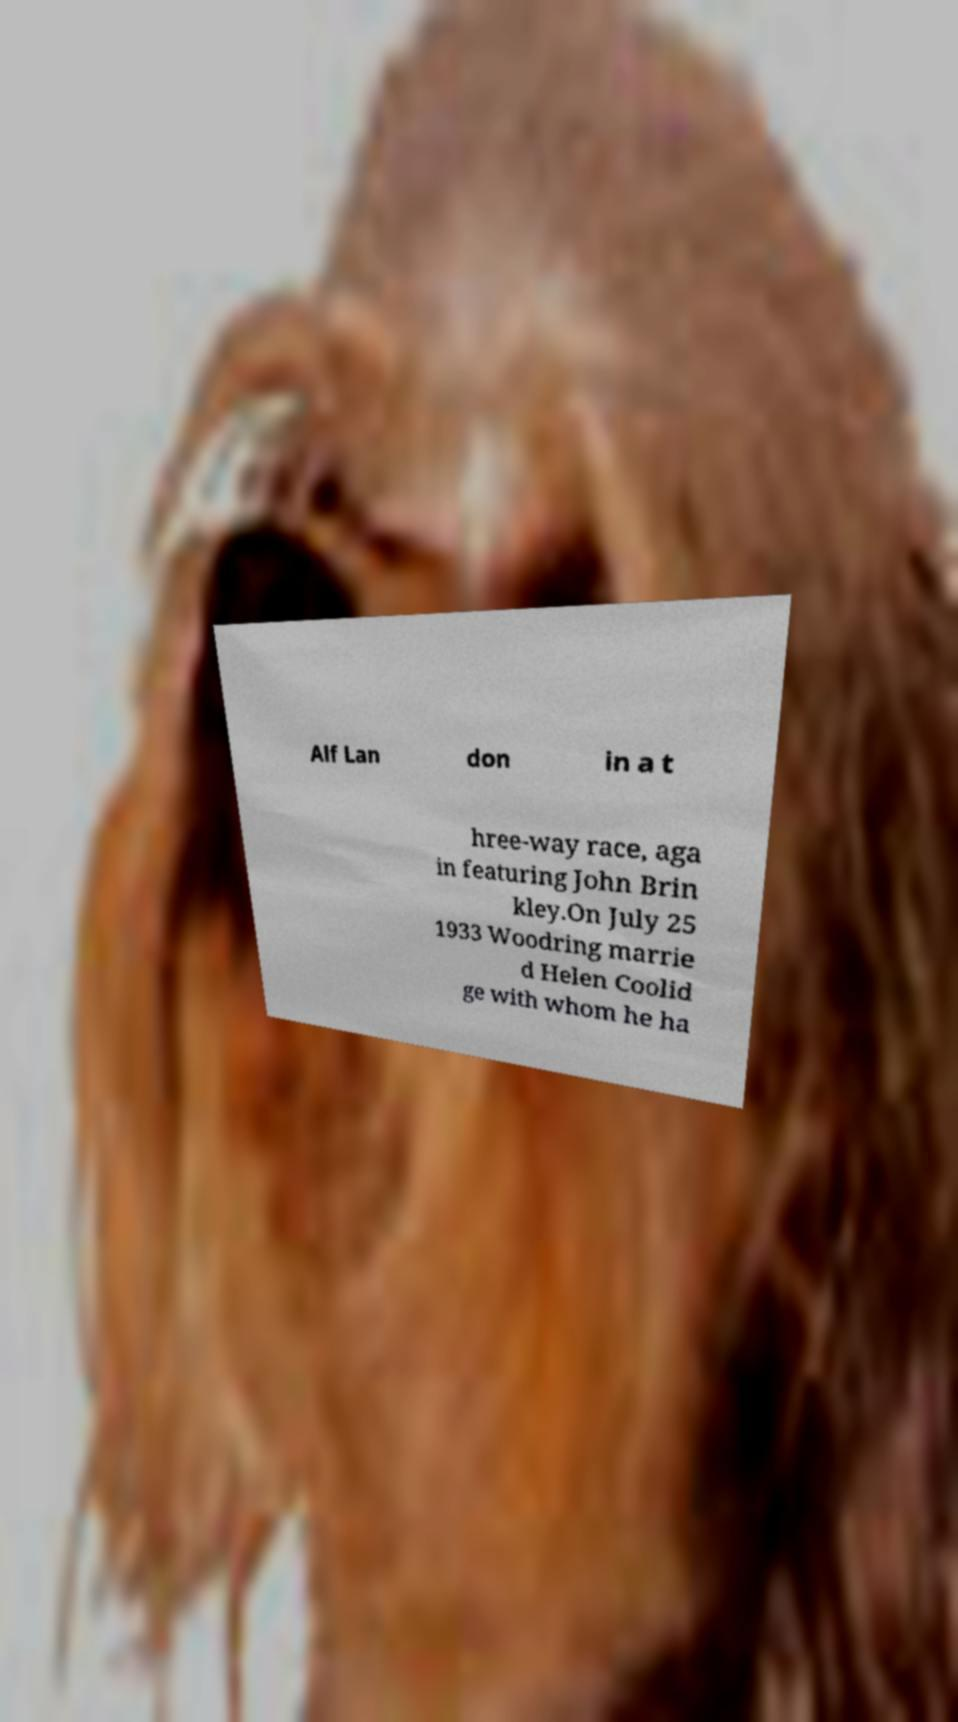Can you accurately transcribe the text from the provided image for me? Alf Lan don in a t hree-way race, aga in featuring John Brin kley.On July 25 1933 Woodring marrie d Helen Coolid ge with whom he ha 